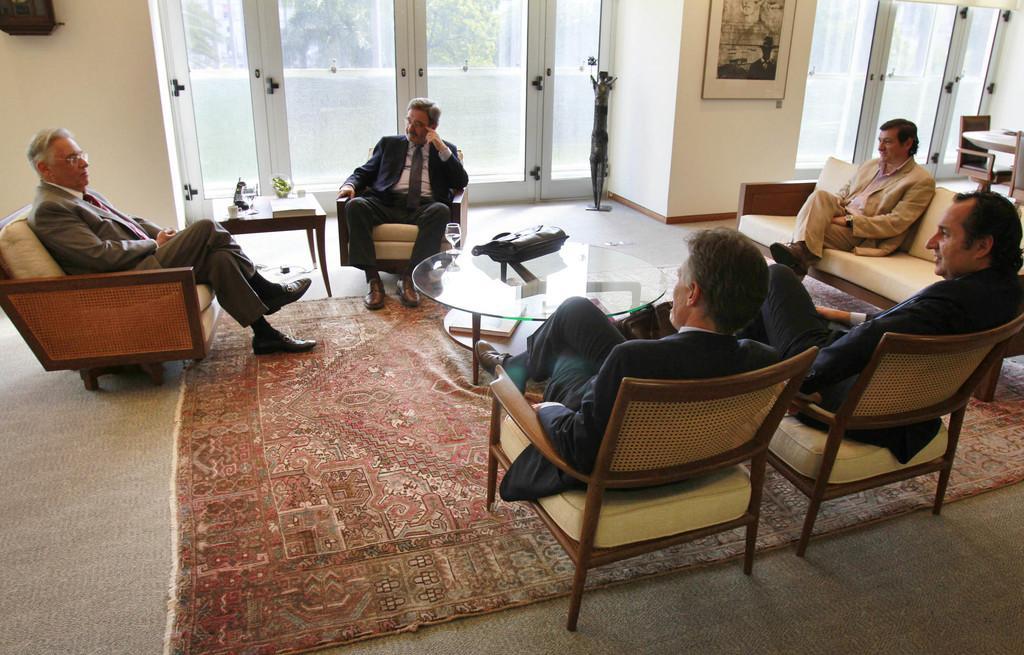How would you summarize this image in a sentence or two? In a room there are five men sitting. In front of them there is a table. On the table there is a bag. And there is a floor mat. In the background there are some doors. To the pillar there is a frame. And to the right side there are some chairs. 